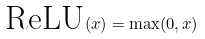<formula> <loc_0><loc_0><loc_500><loc_500>\text {ReLU} ( x ) = \max ( 0 , x )</formula> 